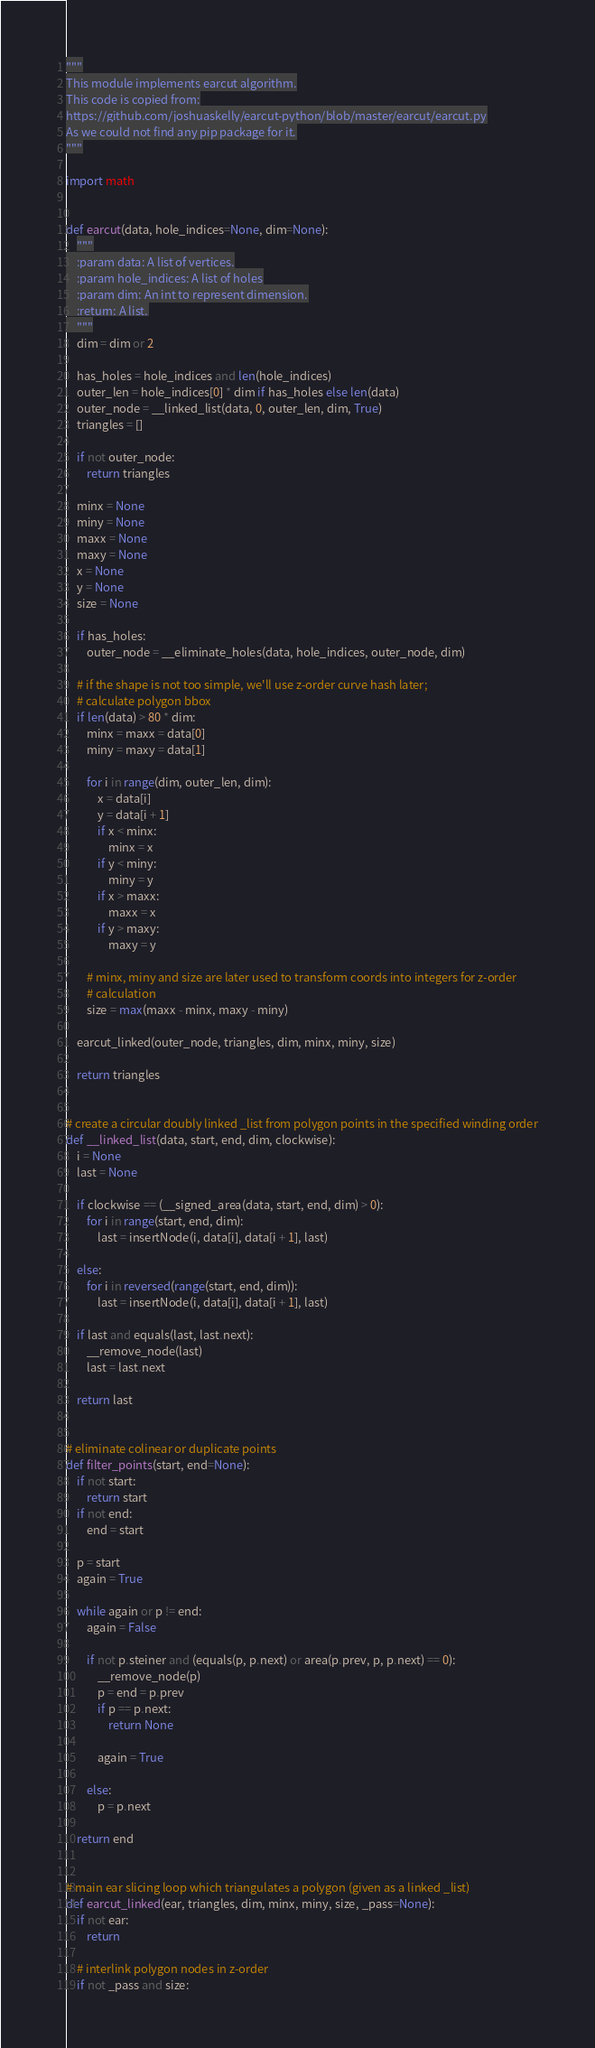Convert code to text. <code><loc_0><loc_0><loc_500><loc_500><_Python_>"""
This module implements earcut algorithm.
This code is copied from:
https://github.com/joshuaskelly/earcut-python/blob/master/earcut/earcut.py
As we could not find any pip package for it.
"""

import math


def earcut(data, hole_indices=None, dim=None):
    """
    :param data: A list of vertices.
    :param hole_indices: A list of holes
    :param dim: An int to represent dimension.
    :return: A list.
    """
    dim = dim or 2

    has_holes = hole_indices and len(hole_indices)
    outer_len = hole_indices[0] * dim if has_holes else len(data)
    outer_node = __linked_list(data, 0, outer_len, dim, True)
    triangles = []

    if not outer_node:
        return triangles

    minx = None
    miny = None
    maxx = None
    maxy = None
    x = None
    y = None
    size = None

    if has_holes:
        outer_node = __eliminate_holes(data, hole_indices, outer_node, dim)

    # if the shape is not too simple, we'll use z-order curve hash later;
    # calculate polygon bbox
    if len(data) > 80 * dim:
        minx = maxx = data[0]
        miny = maxy = data[1]

        for i in range(dim, outer_len, dim):
            x = data[i]
            y = data[i + 1]
            if x < minx:
                minx = x
            if y < miny:
                miny = y
            if x > maxx:
                maxx = x
            if y > maxy:
                maxy = y

        # minx, miny and size are later used to transform coords into integers for z-order
        # calculation
        size = max(maxx - minx, maxy - miny)

    earcut_linked(outer_node, triangles, dim, minx, miny, size)

    return triangles


# create a circular doubly linked _list from polygon points in the specified winding order
def __linked_list(data, start, end, dim, clockwise):
    i = None
    last = None

    if clockwise == (__signed_area(data, start, end, dim) > 0):
        for i in range(start, end, dim):
            last = insertNode(i, data[i], data[i + 1], last)

    else:
        for i in reversed(range(start, end, dim)):
            last = insertNode(i, data[i], data[i + 1], last)

    if last and equals(last, last.next):
        __remove_node(last)
        last = last.next

    return last


# eliminate colinear or duplicate points
def filter_points(start, end=None):
    if not start:
        return start
    if not end:
        end = start

    p = start
    again = True

    while again or p != end:
        again = False

        if not p.steiner and (equals(p, p.next) or area(p.prev, p, p.next) == 0):
            __remove_node(p)
            p = end = p.prev
            if p == p.next:
                return None

            again = True

        else:
            p = p.next

    return end


# main ear slicing loop which triangulates a polygon (given as a linked _list)
def earcut_linked(ear, triangles, dim, minx, miny, size, _pass=None):
    if not ear:
        return

    # interlink polygon nodes in z-order
    if not _pass and size:</code> 